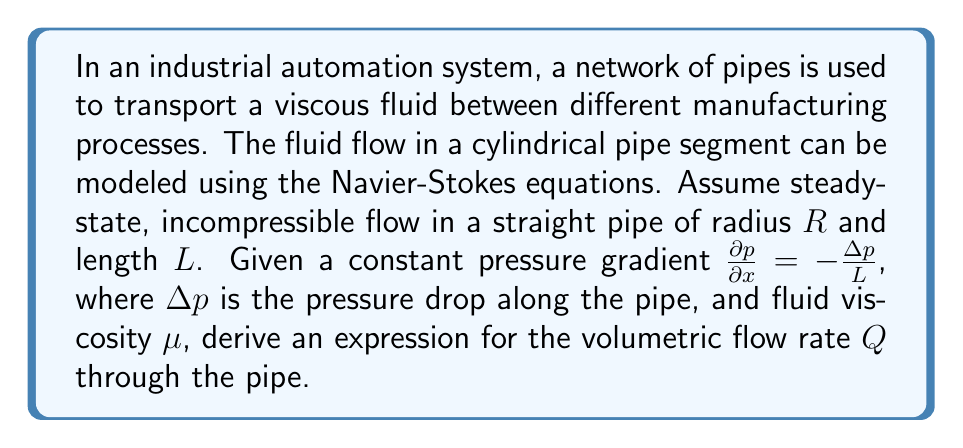What is the answer to this math problem? To solve this problem, we'll follow these steps:

1) First, we consider the Navier-Stokes equation for incompressible, steady-state flow in cylindrical coordinates:

   $$\rho\left(v_r\frac{\partial v_x}{\partial r} + v_x\frac{\partial v_x}{\partial x}\right) = -\frac{\partial p}{\partial x} + \mu\left(\frac{\partial^2v_x}{\partial r^2} + \frac{1}{r}\frac{\partial v_x}{\partial r}\right)$$

2) For fully developed flow in a straight pipe, we can make the following assumptions:
   - $v_r = 0$ (no radial velocity)
   - $\frac{\partial v_x}{\partial x} = 0$ (velocity doesn't change along the pipe)
   - $v_x = v_x(r)$ (velocity only depends on radial position)

3) With these assumptions, the Navier-Stokes equation simplifies to:

   $$0 = -\frac{\partial p}{\partial x} + \mu\left(\frac{d^2v_x}{dr^2} + \frac{1}{r}\frac{dv_x}{dr}\right)$$

4) We can rearrange this equation:

   $$\frac{d^2v_x}{dr^2} + \frac{1}{r}\frac{dv_x}{dr} = \frac{1}{\mu}\frac{\partial p}{\partial x}$$

5) Given that $\frac{\partial p}{\partial x} = -\frac{\Delta p}{L}$, we can rewrite the equation as:

   $$\frac{d^2v_x}{dr^2} + \frac{1}{r}\frac{dv_x}{dr} = -\frac{\Delta p}{\mu L}$$

6) This is a second-order differential equation. We can solve it by integrating twice:

   $$\frac{dv_x}{dr} = -\frac{\Delta p}{2\mu L}r + \frac{C_1}{r}$$

   $$v_x = -\frac{\Delta p}{4\mu L}r^2 + C_1\ln(r) + C_2$$

7) To determine the constants $C_1$ and $C_2$, we use the boundary conditions:
   - At $r = R$, $v_x = 0$ (no-slip condition at the wall)
   - At $r = 0$, $\frac{dv_x}{dr} = 0$ (velocity profile is symmetric)

8) Applying these conditions, we find $C_1 = 0$ and $C_2 = \frac{\Delta p}{4\mu L}R^2$

9) Thus, the velocity profile is:

   $$v_x(r) = \frac{\Delta p}{4\mu L}(R^2 - r^2)$$

10) To find the volumetric flow rate $Q$, we integrate this velocity over the cross-sectional area:

    $$Q = \int_0^R 2\pi r v_x(r) dr = \int_0^R 2\pi r \frac{\Delta p}{4\mu L}(R^2 - r^2) dr$$

11) Solving this integral:

    $$Q = \frac{\pi\Delta p}{8\mu L}R^4$$

This is the well-known Hagen-Poiseuille equation for laminar flow in a pipe.
Answer: $$Q = \frac{\pi\Delta p}{8\mu L}R^4$$ 